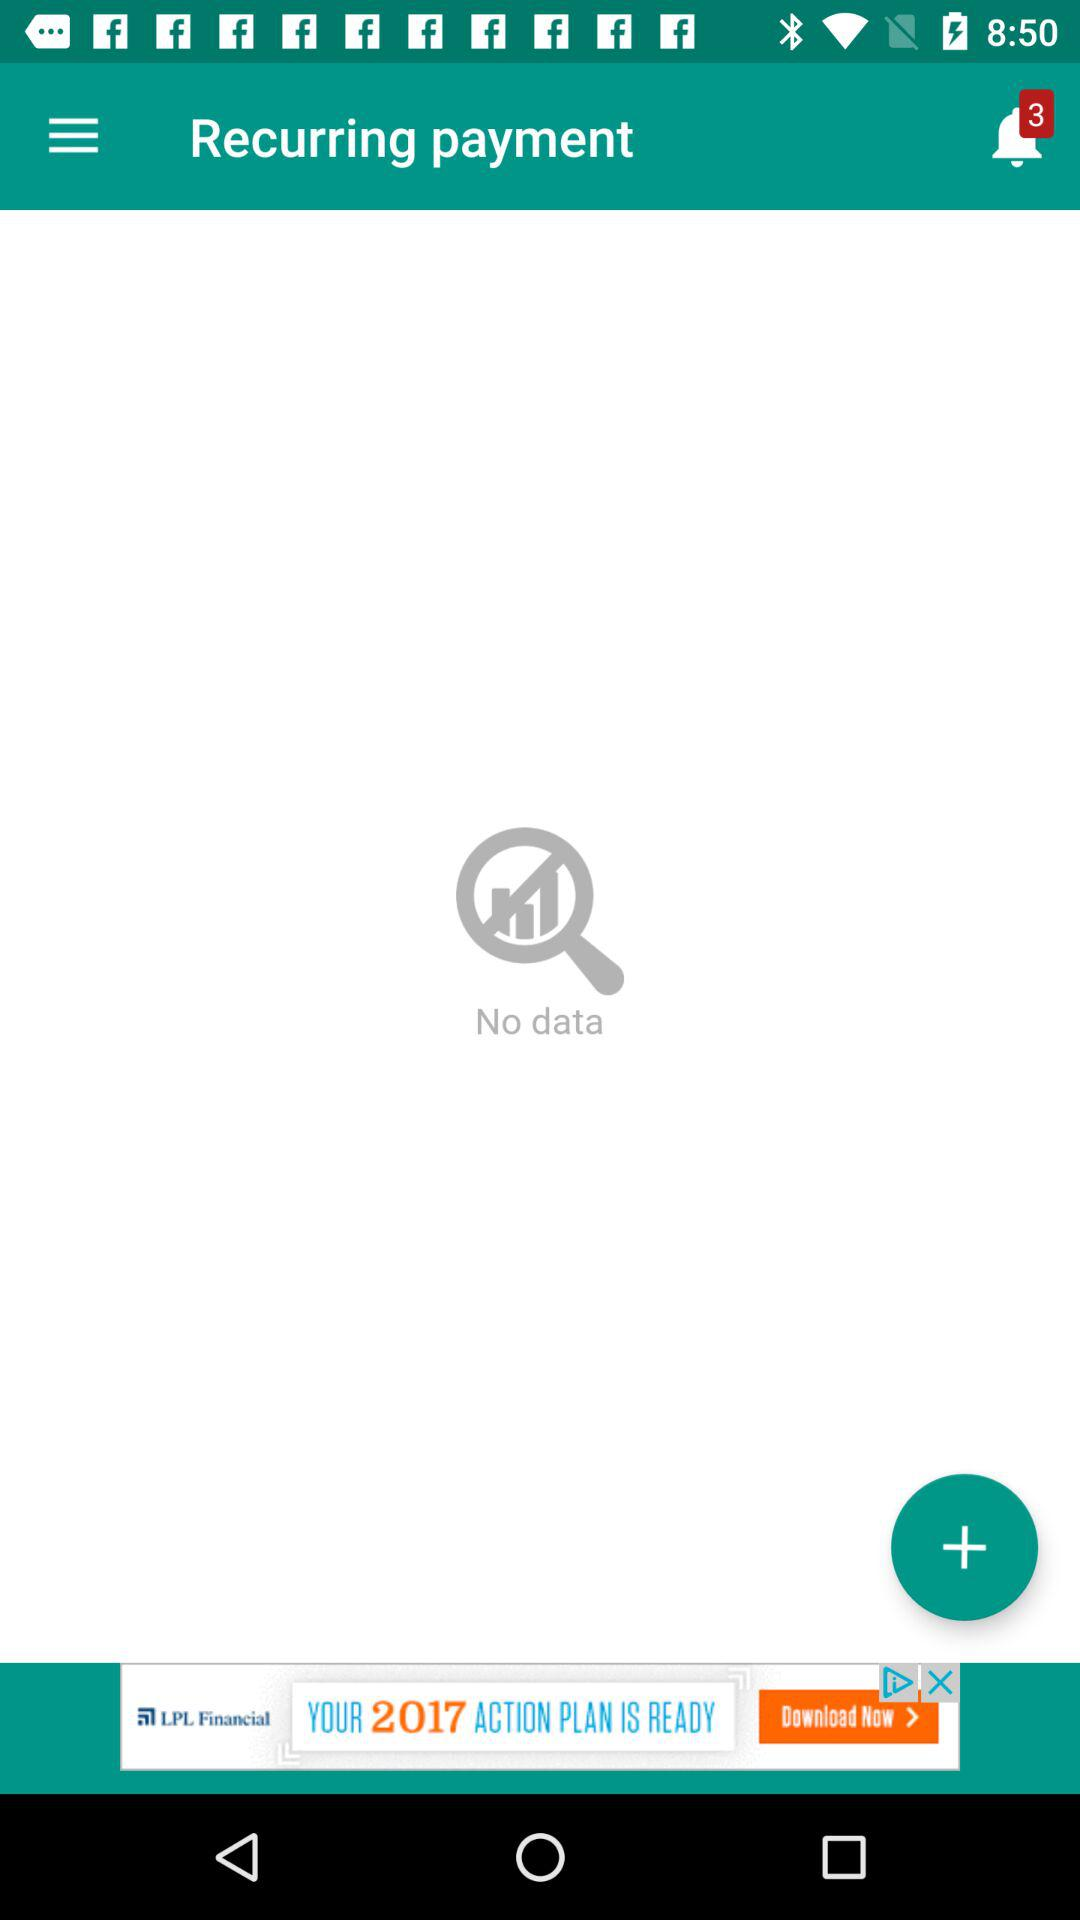What is the number of new notifications? There are 3 new notifications. 